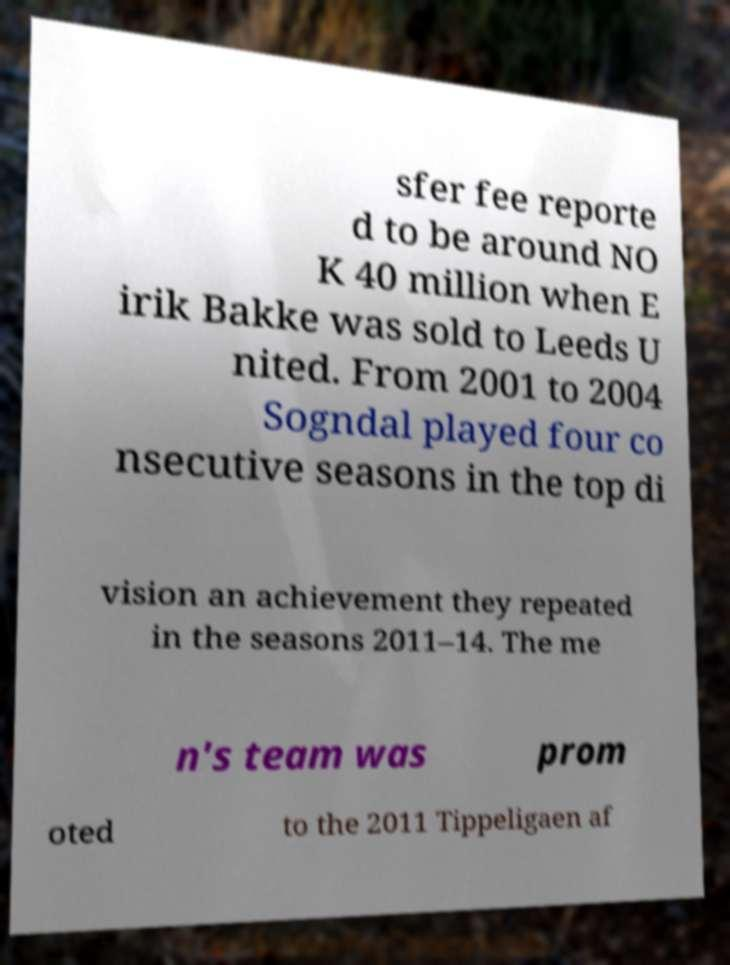Could you extract and type out the text from this image? sfer fee reporte d to be around NO K 40 million when E irik Bakke was sold to Leeds U nited. From 2001 to 2004 Sogndal played four co nsecutive seasons in the top di vision an achievement they repeated in the seasons 2011–14. The me n's team was prom oted to the 2011 Tippeligaen af 